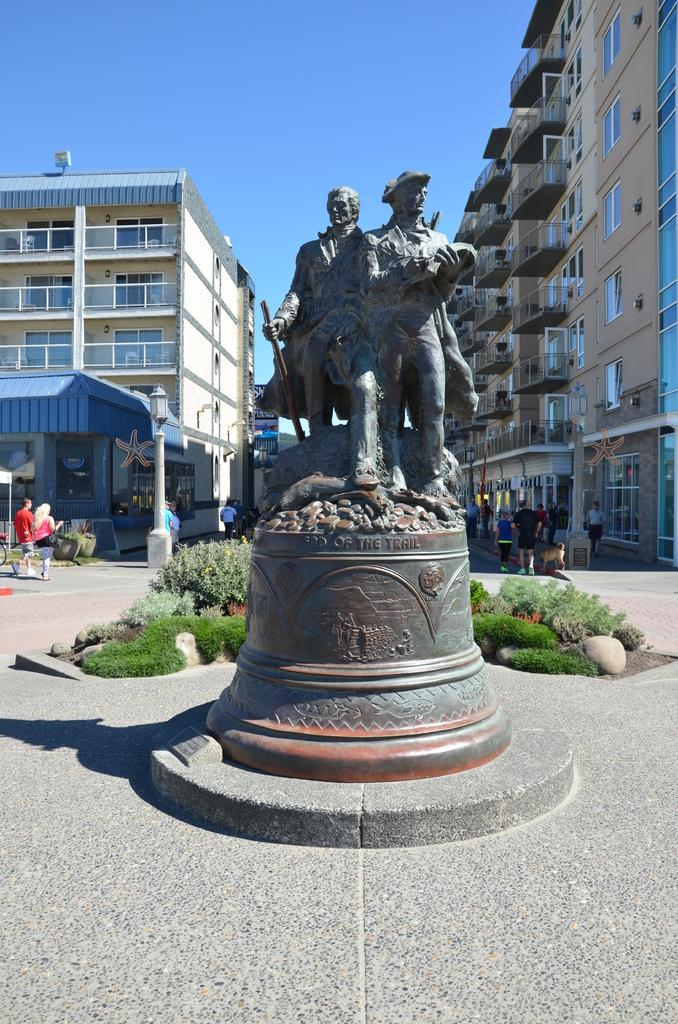What can be seen in the image that represents artistic creations? There are statues in the image. What type of vegetation is present behind the statues? There are plants behind the statues. What structures are present in the image that provide support or guidance? There are poles in the image. Who or what is present in the image that represents human presence or activity? There are people in the image. What type of man-made structures can be seen in the image? There are buildings in the image. What part of the natural environment is visible in the image? The sky is visible behind the buildings. What type of cloth is covering the boats in the image? There are no boats present in the image, so there is no cloth covering them. 